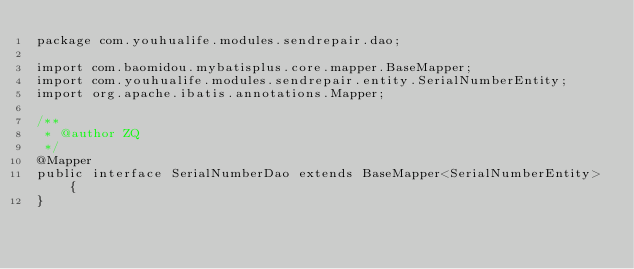Convert code to text. <code><loc_0><loc_0><loc_500><loc_500><_Java_>package com.youhualife.modules.sendrepair.dao;

import com.baomidou.mybatisplus.core.mapper.BaseMapper;
import com.youhualife.modules.sendrepair.entity.SerialNumberEntity;
import org.apache.ibatis.annotations.Mapper;

/**
 * @author ZQ
 */
@Mapper
public interface SerialNumberDao extends BaseMapper<SerialNumberEntity> {
}
</code> 